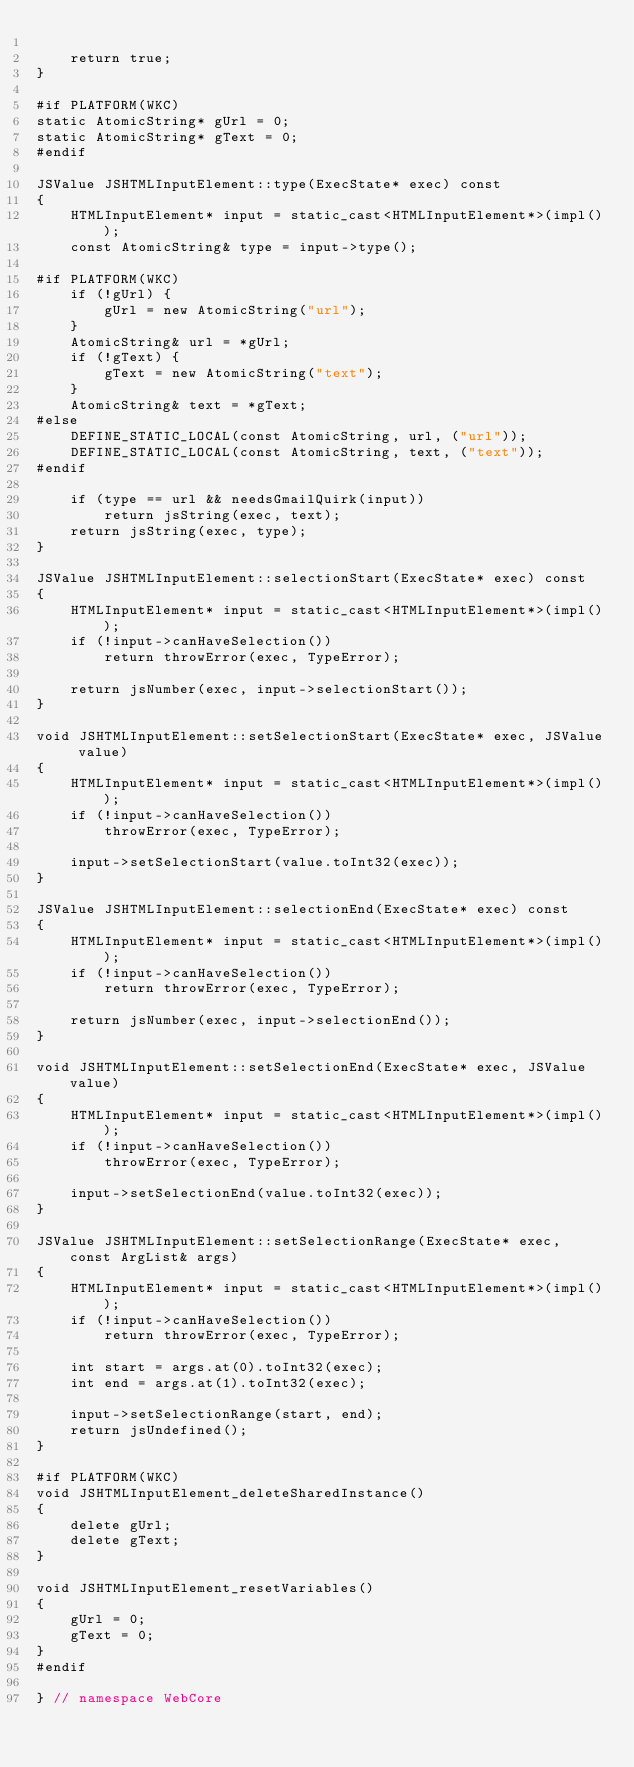<code> <loc_0><loc_0><loc_500><loc_500><_C++_>
    return true;
}

#if PLATFORM(WKC)
static AtomicString* gUrl = 0;
static AtomicString* gText = 0;
#endif

JSValue JSHTMLInputElement::type(ExecState* exec) const
{
    HTMLInputElement* input = static_cast<HTMLInputElement*>(impl());
    const AtomicString& type = input->type();

#if PLATFORM(WKC)
    if (!gUrl) {
        gUrl = new AtomicString("url");
    }
    AtomicString& url = *gUrl;
    if (!gText) {
        gText = new AtomicString("text");
    }
    AtomicString& text = *gText;
#else
    DEFINE_STATIC_LOCAL(const AtomicString, url, ("url"));
    DEFINE_STATIC_LOCAL(const AtomicString, text, ("text"));
#endif

    if (type == url && needsGmailQuirk(input))
        return jsString(exec, text);
    return jsString(exec, type);
}

JSValue JSHTMLInputElement::selectionStart(ExecState* exec) const
{
    HTMLInputElement* input = static_cast<HTMLInputElement*>(impl());
    if (!input->canHaveSelection())
        return throwError(exec, TypeError);

    return jsNumber(exec, input->selectionStart());
}

void JSHTMLInputElement::setSelectionStart(ExecState* exec, JSValue value)
{
    HTMLInputElement* input = static_cast<HTMLInputElement*>(impl());
    if (!input->canHaveSelection())
        throwError(exec, TypeError);

    input->setSelectionStart(value.toInt32(exec));
}

JSValue JSHTMLInputElement::selectionEnd(ExecState* exec) const
{
    HTMLInputElement* input = static_cast<HTMLInputElement*>(impl());
    if (!input->canHaveSelection())
        return throwError(exec, TypeError);

    return jsNumber(exec, input->selectionEnd());
}

void JSHTMLInputElement::setSelectionEnd(ExecState* exec, JSValue value)
{
    HTMLInputElement* input = static_cast<HTMLInputElement*>(impl());
    if (!input->canHaveSelection())
        throwError(exec, TypeError);

    input->setSelectionEnd(value.toInt32(exec));
}

JSValue JSHTMLInputElement::setSelectionRange(ExecState* exec, const ArgList& args)
{
    HTMLInputElement* input = static_cast<HTMLInputElement*>(impl());
    if (!input->canHaveSelection())
        return throwError(exec, TypeError);

    int start = args.at(0).toInt32(exec);
    int end = args.at(1).toInt32(exec);

    input->setSelectionRange(start, end);
    return jsUndefined();
}

#if PLATFORM(WKC)
void JSHTMLInputElement_deleteSharedInstance()
{
    delete gUrl;
    delete gText;
}

void JSHTMLInputElement_resetVariables()
{
    gUrl = 0;
    gText = 0;
}
#endif

} // namespace WebCore
</code> 